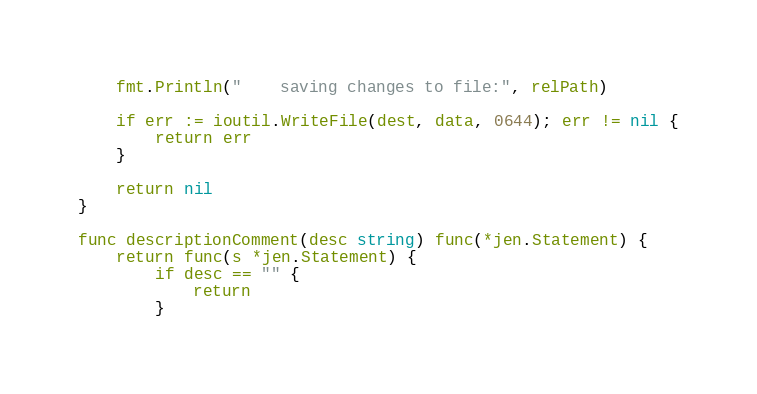Convert code to text. <code><loc_0><loc_0><loc_500><loc_500><_Go_>
	fmt.Println("    saving changes to file:", relPath)

	if err := ioutil.WriteFile(dest, data, 0644); err != nil {
		return err
	}

	return nil
}

func descriptionComment(desc string) func(*jen.Statement) {
	return func(s *jen.Statement) {
		if desc == "" {
			return
		}</code> 